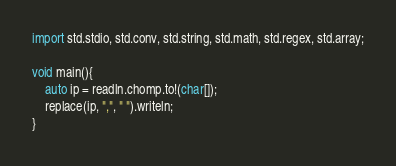<code> <loc_0><loc_0><loc_500><loc_500><_D_>import std.stdio, std.conv, std.string, std.math, std.regex, std.array;

void main(){
	auto ip = readln.chomp.to!(char[]);
	replace(ip, ",", " ").writeln;
}</code> 